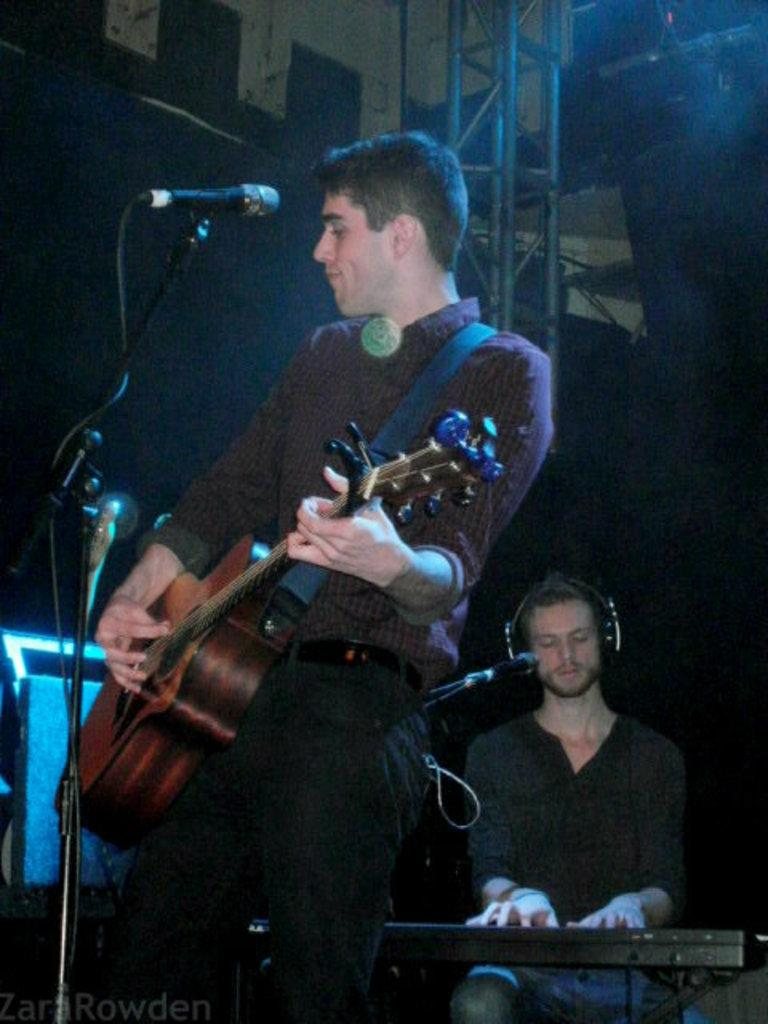What is the man in the image doing with the guitar? The man is holding and playing a guitar in the image. What is the other man in the image doing? The other man is sitting and playing a piano in the image. What object is present in the image that is commonly used for amplifying sound? There is a microphone (mic) in the image. How many chickens can be seen in the image? There are no chickens present in the image. What type of truck is visible in the background of the image? There is no truck visible in the image. 